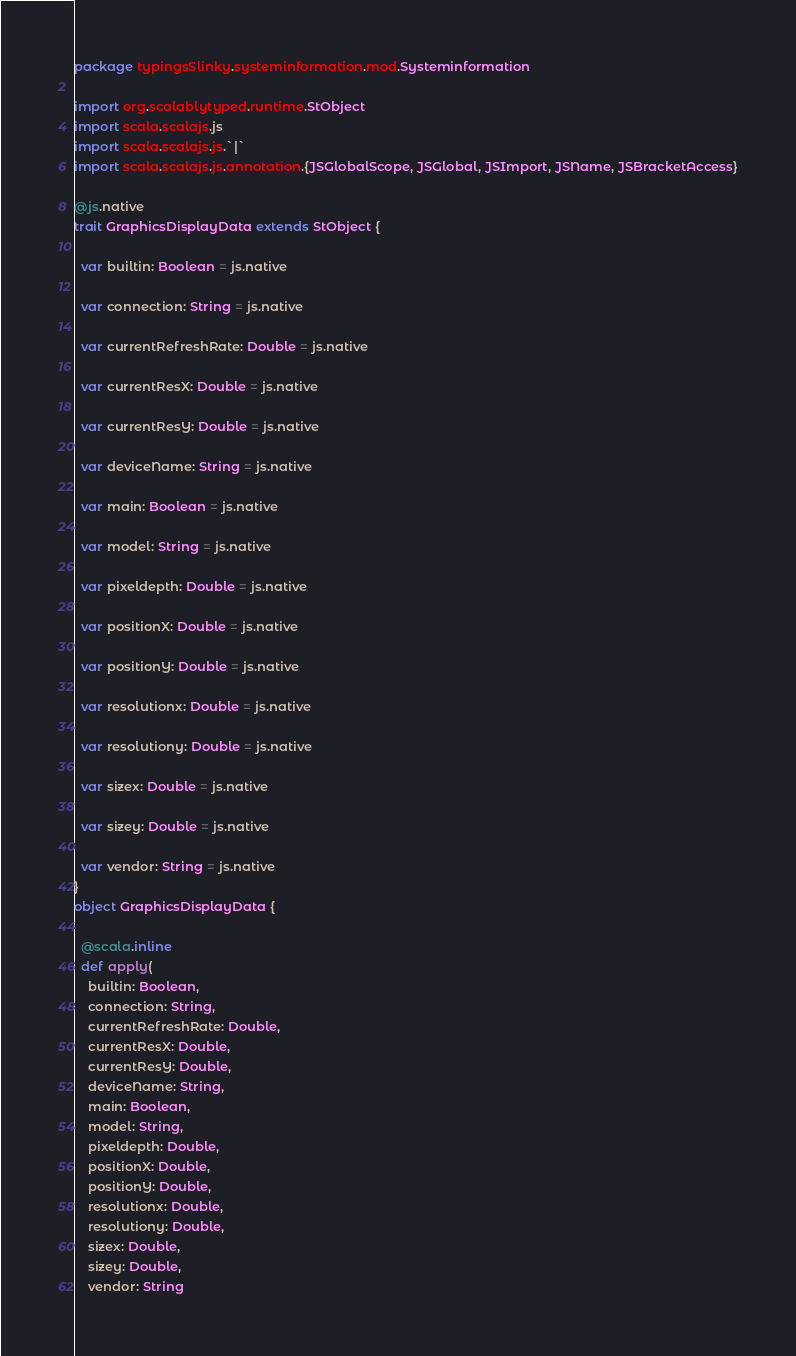Convert code to text. <code><loc_0><loc_0><loc_500><loc_500><_Scala_>package typingsSlinky.systeminformation.mod.Systeminformation

import org.scalablytyped.runtime.StObject
import scala.scalajs.js
import scala.scalajs.js.`|`
import scala.scalajs.js.annotation.{JSGlobalScope, JSGlobal, JSImport, JSName, JSBracketAccess}

@js.native
trait GraphicsDisplayData extends StObject {
  
  var builtin: Boolean = js.native
  
  var connection: String = js.native
  
  var currentRefreshRate: Double = js.native
  
  var currentResX: Double = js.native
  
  var currentResY: Double = js.native
  
  var deviceName: String = js.native
  
  var main: Boolean = js.native
  
  var model: String = js.native
  
  var pixeldepth: Double = js.native
  
  var positionX: Double = js.native
  
  var positionY: Double = js.native
  
  var resolutionx: Double = js.native
  
  var resolutiony: Double = js.native
  
  var sizex: Double = js.native
  
  var sizey: Double = js.native
  
  var vendor: String = js.native
}
object GraphicsDisplayData {
  
  @scala.inline
  def apply(
    builtin: Boolean,
    connection: String,
    currentRefreshRate: Double,
    currentResX: Double,
    currentResY: Double,
    deviceName: String,
    main: Boolean,
    model: String,
    pixeldepth: Double,
    positionX: Double,
    positionY: Double,
    resolutionx: Double,
    resolutiony: Double,
    sizex: Double,
    sizey: Double,
    vendor: String</code> 